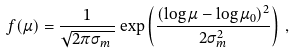Convert formula to latex. <formula><loc_0><loc_0><loc_500><loc_500>f ( \mu ) = \frac { 1 } { \sqrt { 2 \pi \sigma _ { m } \, } } \exp \left ( \frac { ( \log \mu - \log \mu _ { 0 } ) ^ { 2 } } { 2 \sigma _ { m } ^ { 2 } } \right ) \, ,</formula> 